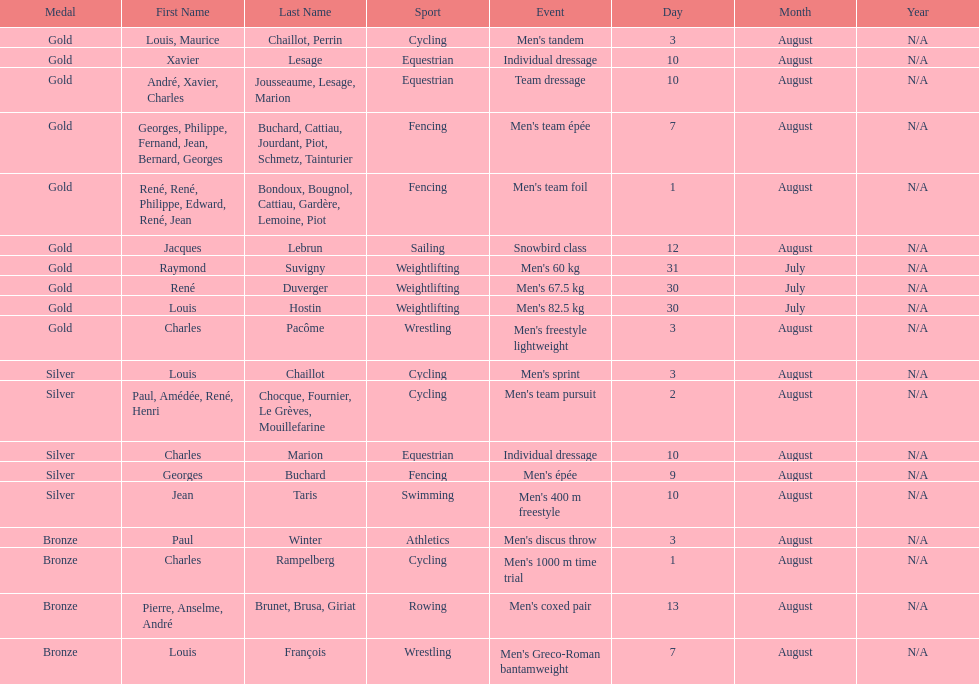How many gold medals did this country win during these olympics? 10. 